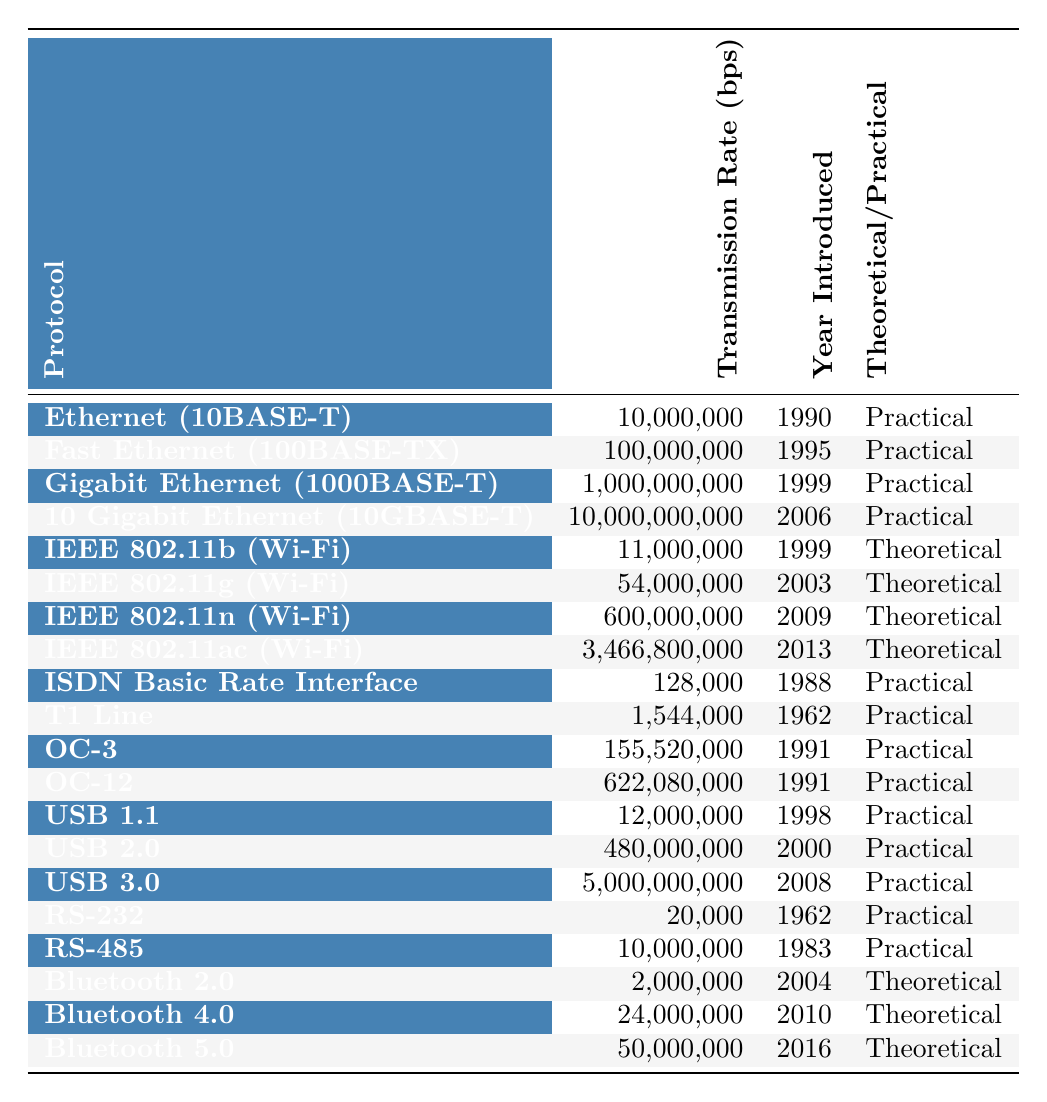What is the transmission rate of Gigabit Ethernet (1000BASE-T)? Referring to the table, the transmission rate for Gigabit Ethernet (1000BASE-T) is listed as 1,000,000,000 bits per second.
Answer: 1,000,000,000 bps Which protocol was introduced first: USB 1.1 or T1 Line? Looking at the year introduced for each protocol, USB 1.1 was introduced in 1998 and T1 Line in 1962. Since 1962 is earlier than 1998, T1 Line was introduced first.
Answer: T1 Line What is the difference in transmission rates between 10 Gigabit Ethernet (10GBASE-T) and OC-12? The transmission rate for 10 Gigabit Ethernet (10GBASE-T) is 10,000,000,000 bps and for OC-12 it is 622,080,000 bps. The difference can be calculated as 10,000,000,000 - 622,080,000 = 9,377,920,000 bits per second.
Answer: 9,377,920,000 bps What is the average transmission rate of the Bluetooth protocols listed in the table? There are three Bluetooth protocols with transmission rates: Bluetooth 2.0 (2,000,000 bps), Bluetooth 4.0 (24,000,000 bps), and Bluetooth 5.0 (50,000,000 bps). Summing these gives 2,000,000 + 24,000,000 + 50,000,000 = 76,000,000 bps. The average is calculated by dividing the total by 3, which yields 76,000,000 / 3 = 25,333,333.33.
Answer: 25,333,333 bps Is the transmission rate of USB 2.0 higher than that of Ethernet (10BASE-T)? USB 2.0 has a transmission rate of 480,000,000 bps and Ethernet (10BASE-T) has 10,000,000 bps. Since 480,000,000 is greater than 10,000,000, it is true that USB 2.0's rate is higher.
Answer: Yes What percentage of the protocols listed are classified as theoretical? There are 20 total protocols listed and 8 are classified as theoretical. The percentage is calculated by taking (8/20) * 100, resulting in 40%.
Answer: 40% 